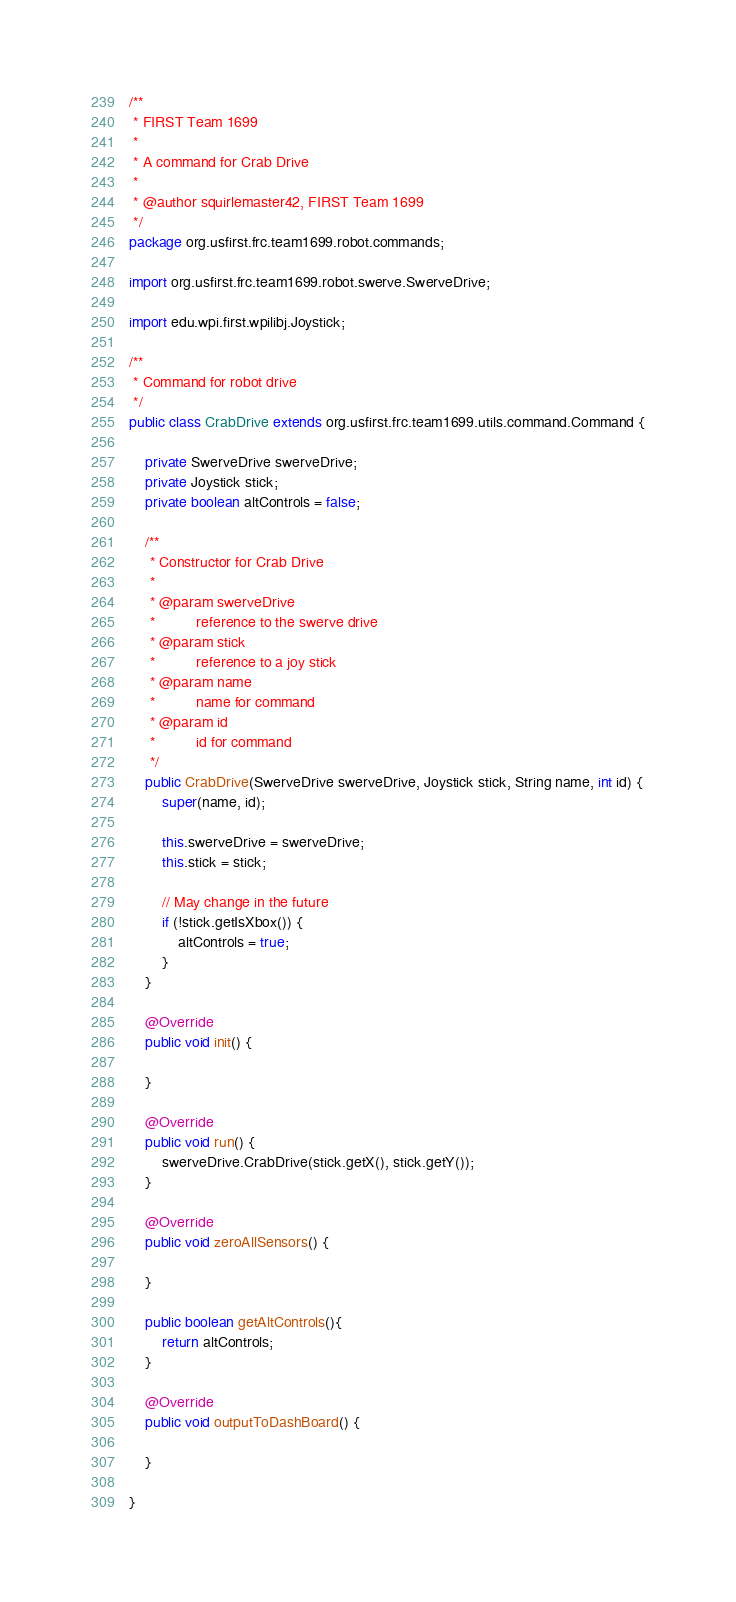<code> <loc_0><loc_0><loc_500><loc_500><_Java_>/**
 * FIRST Team 1699
 * 
 * A command for Crab Drive
 * 
 * @author squirlemaster42, FIRST Team 1699
 */
package org.usfirst.frc.team1699.robot.commands;

import org.usfirst.frc.team1699.robot.swerve.SwerveDrive;

import edu.wpi.first.wpilibj.Joystick;

/**
 * Command for robot drive
 */
public class CrabDrive extends org.usfirst.frc.team1699.utils.command.Command {
	
	private SwerveDrive swerveDrive;
	private Joystick stick;
	private boolean altControls = false;
	
	/**
	 * Constructor for Crab Drive
	 * 
	 * @param swerveDrive
	 * 			reference to the swerve drive
	 * @param stick
	 * 			reference to a joy stick
	 * @param name
	 * 			name for command
	 * @param id
	 * 			id for command
	 */
	public CrabDrive(SwerveDrive swerveDrive, Joystick stick, String name, int id) {
		super(name, id);

		this.swerveDrive = swerveDrive;
		this.stick = stick;

		// May change in the future
		if (!stick.getIsXbox()) {
			altControls = true;
		}
	}

	@Override
	public void init() {

	}

	@Override
	public void run() {
		swerveDrive.CrabDrive(stick.getX(), stick.getY());
	}

	@Override
	public void zeroAllSensors() {

	}
	
	public boolean getAltControls(){
		return altControls;
	}
	
	@Override
	public void outputToDashBoard() {
		
	}
	
}
</code> 